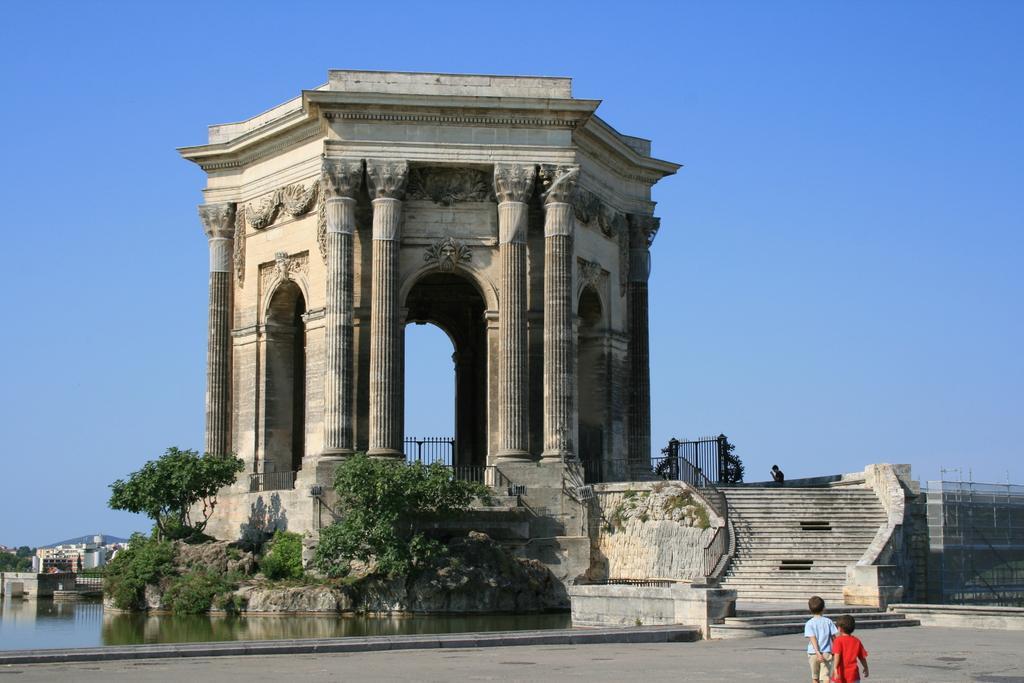Could you give a brief overview of what you see in this image? In this picture I can see Plaza Real Del Peyrou, there is water, there are trees, buildings, iron grilles, stairs, there are two kids standing, and in the background there is sky. 